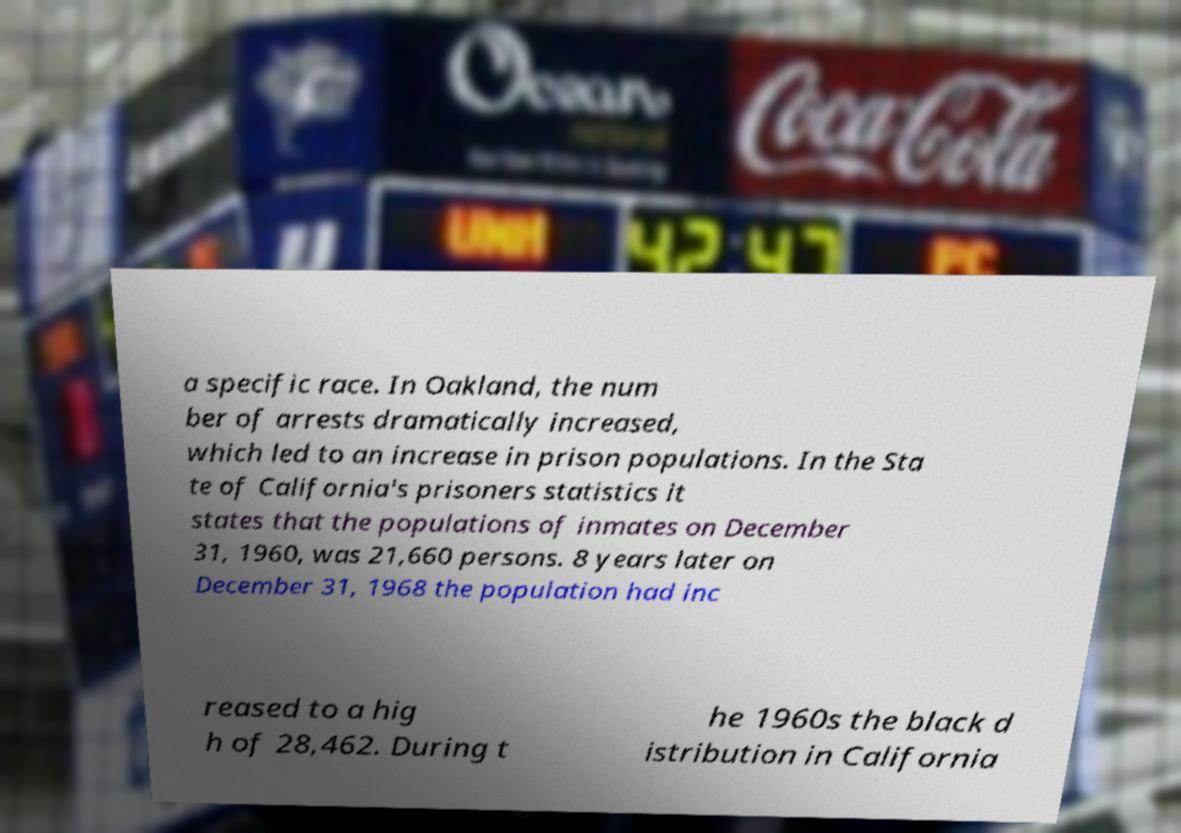Please read and relay the text visible in this image. What does it say? a specific race. In Oakland, the num ber of arrests dramatically increased, which led to an increase in prison populations. In the Sta te of California's prisoners statistics it states that the populations of inmates on December 31, 1960, was 21,660 persons. 8 years later on December 31, 1968 the population had inc reased to a hig h of 28,462. During t he 1960s the black d istribution in California 